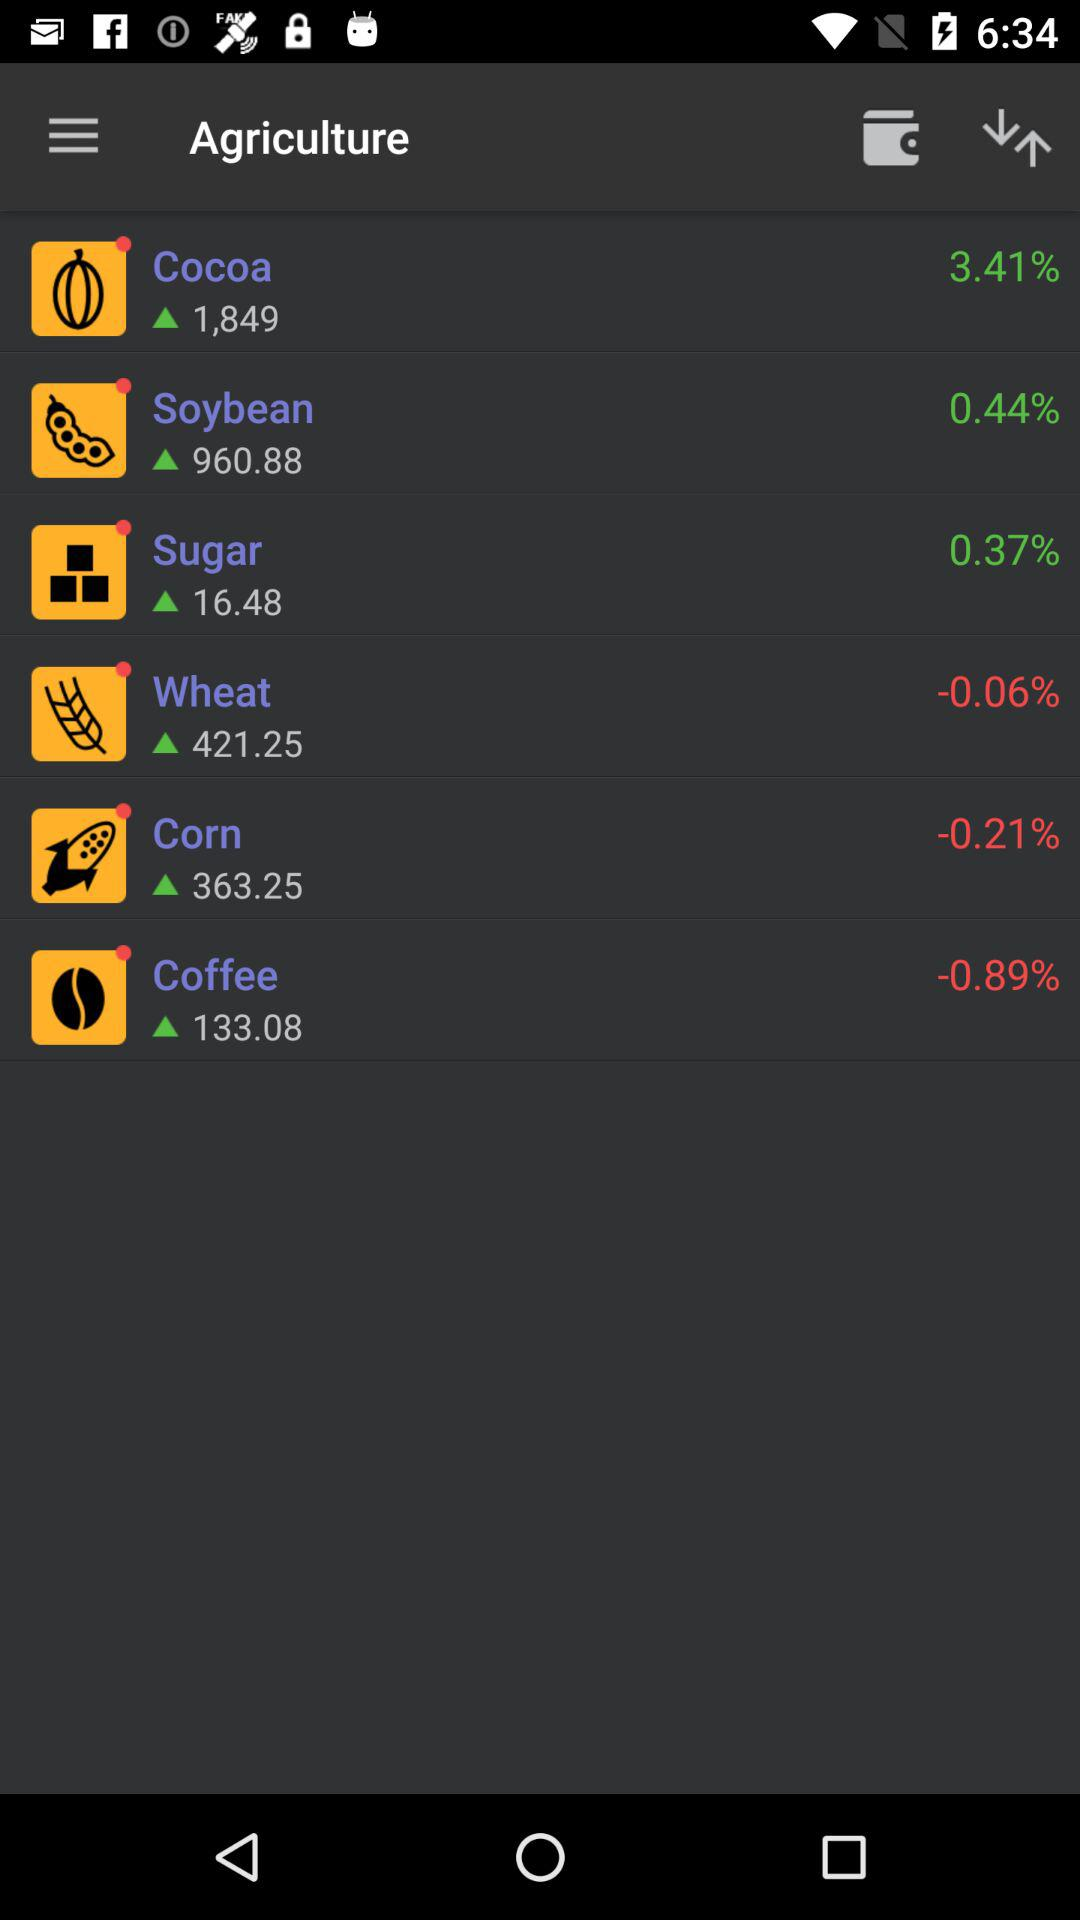What is the percentage decrease in corn production? The percentage decrease is -0.21. 